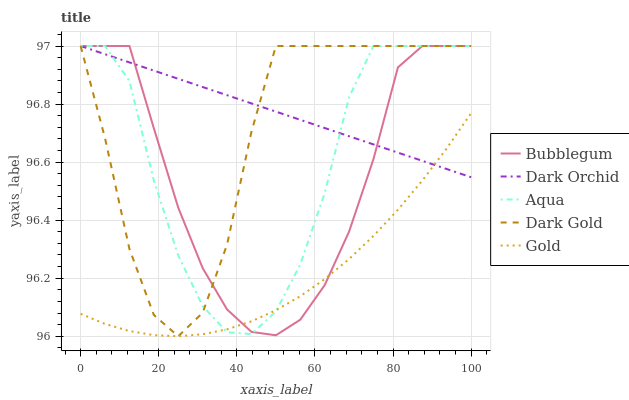Does Gold have the minimum area under the curve?
Answer yes or no. Yes. Does Dark Orchid have the maximum area under the curve?
Answer yes or no. Yes. Does Aqua have the minimum area under the curve?
Answer yes or no. No. Does Aqua have the maximum area under the curve?
Answer yes or no. No. Is Dark Orchid the smoothest?
Answer yes or no. Yes. Is Aqua the roughest?
Answer yes or no. Yes. Is Aqua the smoothest?
Answer yes or no. No. Is Dark Orchid the roughest?
Answer yes or no. No. Does Dark Gold have the lowest value?
Answer yes or no. Yes. Does Aqua have the lowest value?
Answer yes or no. No. Does Dark Gold have the highest value?
Answer yes or no. Yes. Does Gold intersect Aqua?
Answer yes or no. Yes. Is Gold less than Aqua?
Answer yes or no. No. Is Gold greater than Aqua?
Answer yes or no. No. 